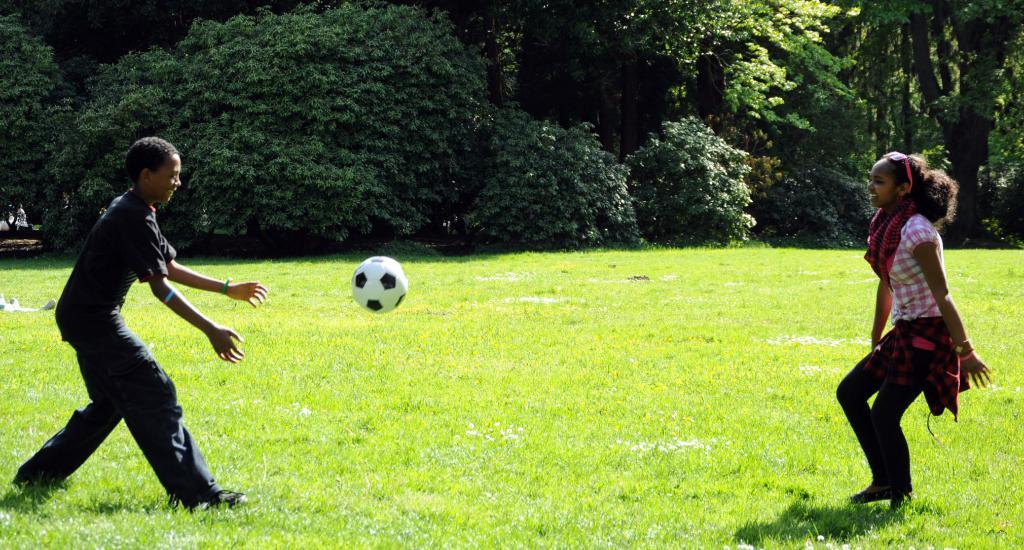How many people are in the image? There are two people in the image. What are the people doing in the image? The people are on the grass and smiling. What is happening with the ball in the image? The ball is in the air. What can be seen in the background of the image? There are trees and plants in the background of the image. What type of paper is the monkey holding in the image? There is no monkey present in the image, and therefore no paper or object held by a monkey can be observed. 